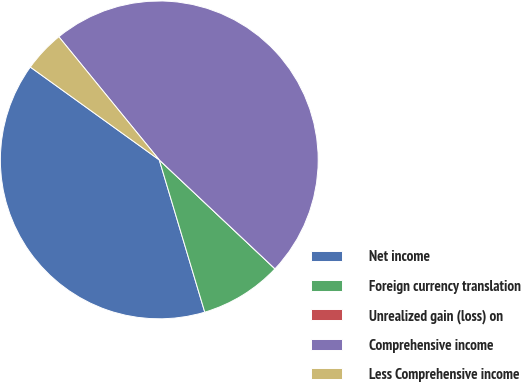Convert chart. <chart><loc_0><loc_0><loc_500><loc_500><pie_chart><fcel>Net income<fcel>Foreign currency translation<fcel>Unrealized gain (loss) on<fcel>Comprehensive income<fcel>Less Comprehensive income<nl><fcel>39.55%<fcel>8.36%<fcel>0.0%<fcel>47.91%<fcel>4.18%<nl></chart> 